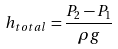Convert formula to latex. <formula><loc_0><loc_0><loc_500><loc_500>h _ { t o t a l } = \frac { P _ { 2 } - P _ { 1 } } { \rho g }</formula> 